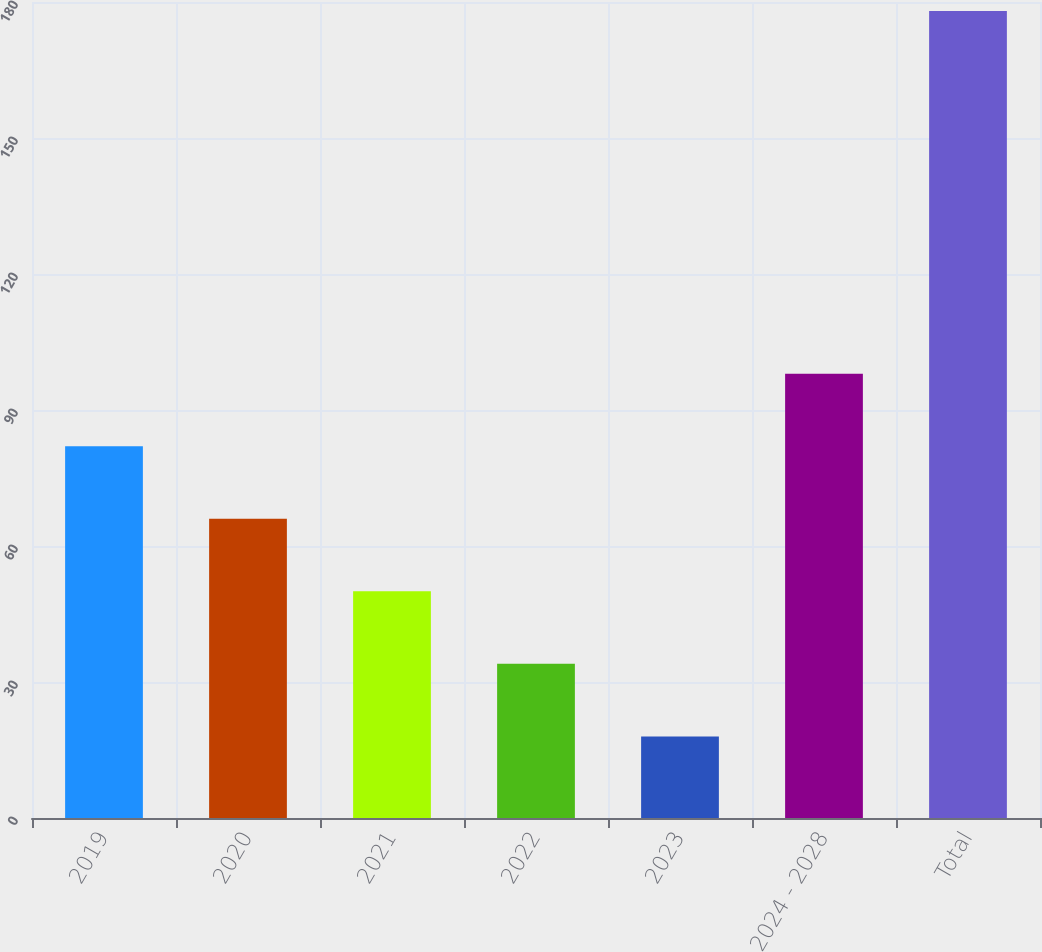<chart> <loc_0><loc_0><loc_500><loc_500><bar_chart><fcel>2019<fcel>2020<fcel>2021<fcel>2022<fcel>2023<fcel>2024 - 2028<fcel>Total<nl><fcel>82<fcel>66<fcel>50<fcel>34<fcel>18<fcel>98<fcel>178<nl></chart> 